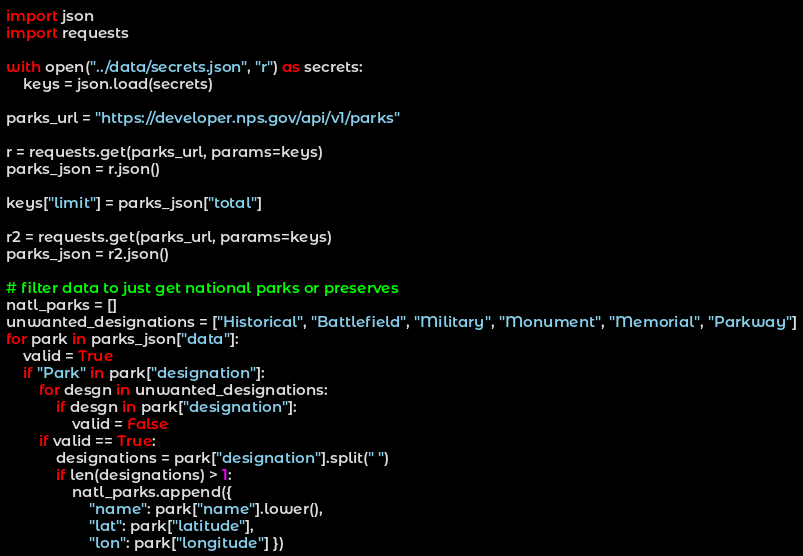<code> <loc_0><loc_0><loc_500><loc_500><_Python_>import json
import requests

with open("../data/secrets.json", "r") as secrets:
    keys = json.load(secrets)

parks_url = "https://developer.nps.gov/api/v1/parks"

r = requests.get(parks_url, params=keys)
parks_json = r.json()

keys["limit"] = parks_json["total"]

r2 = requests.get(parks_url, params=keys)
parks_json = r2.json()

# filter data to just get national parks or preserves
natl_parks = []
unwanted_designations = ["Historical", "Battlefield", "Military", "Monument", "Memorial", "Parkway"]
for park in parks_json["data"]:
    valid = True
    if "Park" in park["designation"]:
        for desgn in unwanted_designations:
            if desgn in park["designation"]:
                valid = False
        if valid == True:
            designations = park["designation"].split(" ")
            if len(designations) > 1:
                natl_parks.append({
                    "name": park["name"].lower(), 
                    "lat": park["latitude"], 
                    "lon": park["longitude"] })
</code> 